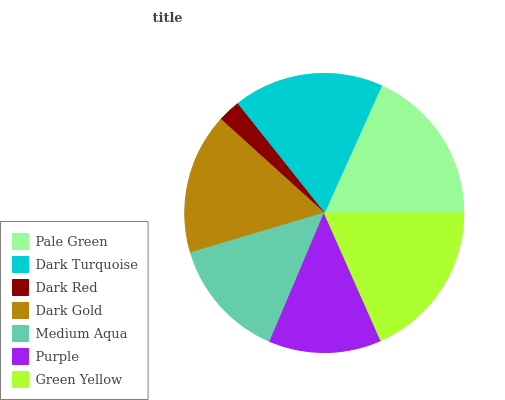Is Dark Red the minimum?
Answer yes or no. Yes. Is Green Yellow the maximum?
Answer yes or no. Yes. Is Dark Turquoise the minimum?
Answer yes or no. No. Is Dark Turquoise the maximum?
Answer yes or no. No. Is Pale Green greater than Dark Turquoise?
Answer yes or no. Yes. Is Dark Turquoise less than Pale Green?
Answer yes or no. Yes. Is Dark Turquoise greater than Pale Green?
Answer yes or no. No. Is Pale Green less than Dark Turquoise?
Answer yes or no. No. Is Dark Gold the high median?
Answer yes or no. Yes. Is Dark Gold the low median?
Answer yes or no. Yes. Is Green Yellow the high median?
Answer yes or no. No. Is Green Yellow the low median?
Answer yes or no. No. 